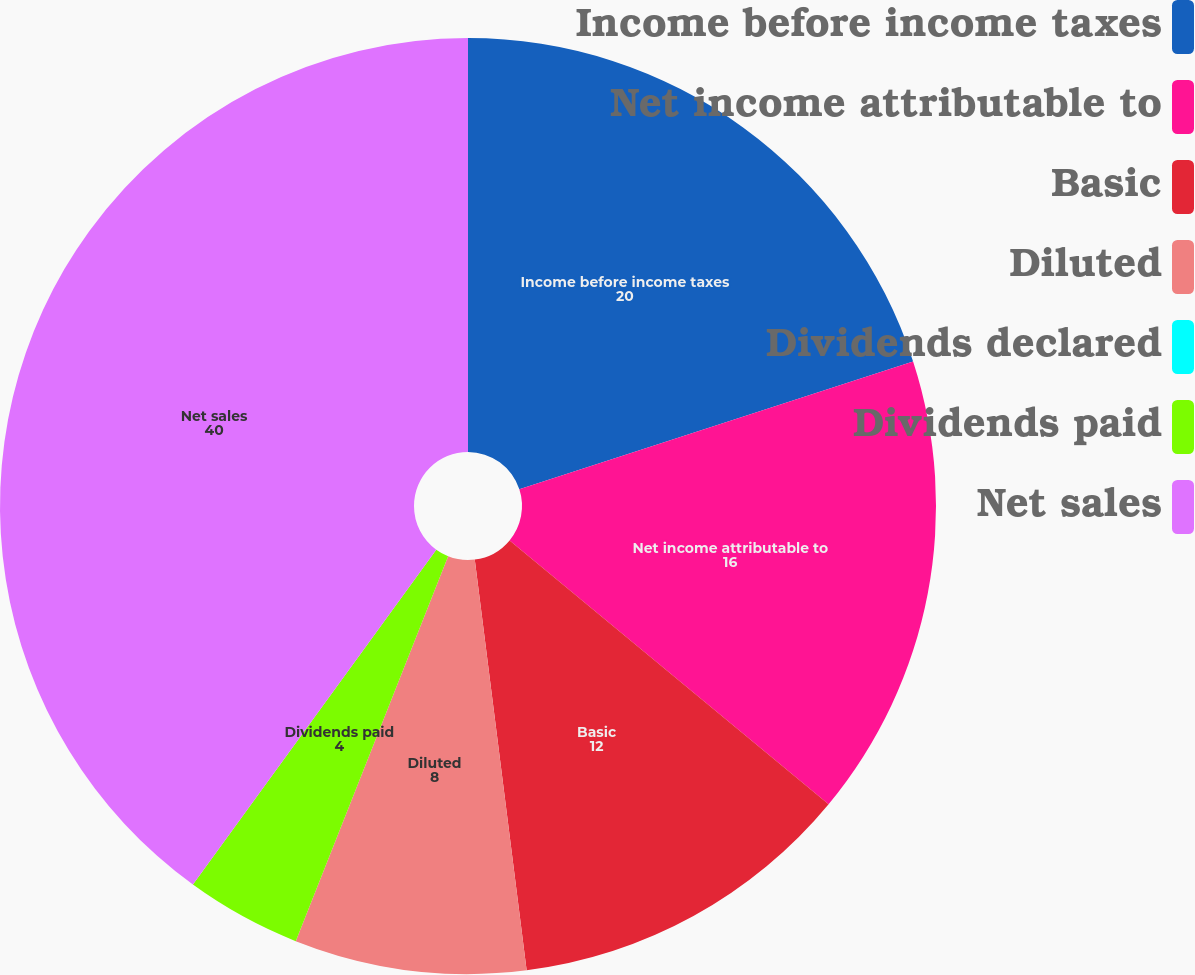Convert chart. <chart><loc_0><loc_0><loc_500><loc_500><pie_chart><fcel>Income before income taxes<fcel>Net income attributable to<fcel>Basic<fcel>Diluted<fcel>Dividends declared<fcel>Dividends paid<fcel>Net sales<nl><fcel>20.0%<fcel>16.0%<fcel>12.0%<fcel>8.0%<fcel>0.0%<fcel>4.0%<fcel>40.0%<nl></chart> 